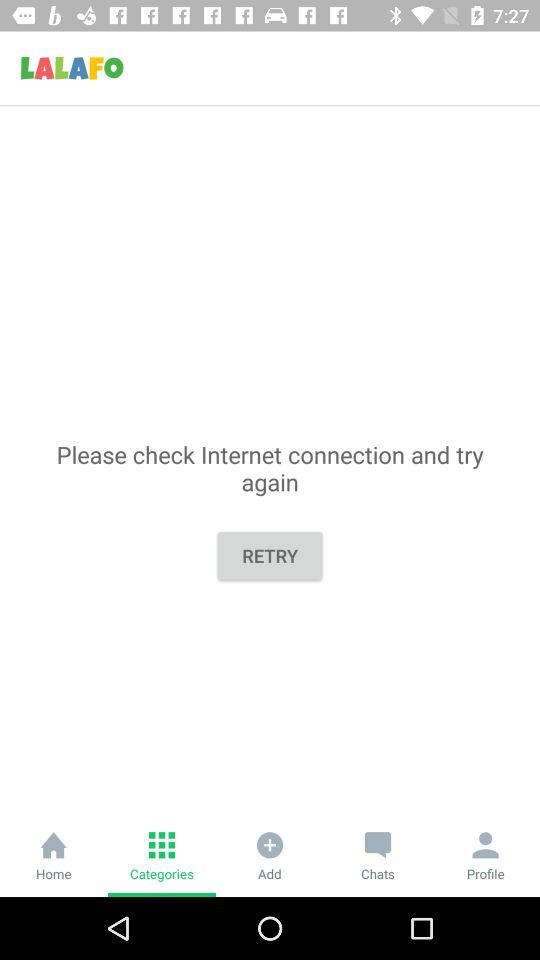What is the name of the application? The name of the application is "LALAFO". 